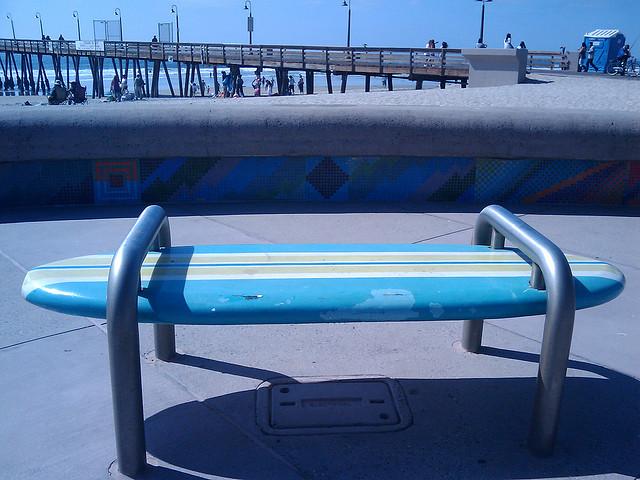What water sport item is the bench shaped like?
Answer briefly. Surfboard. What color is the board?
Give a very brief answer. Blue. Is this a bench?
Short answer required. Yes. 